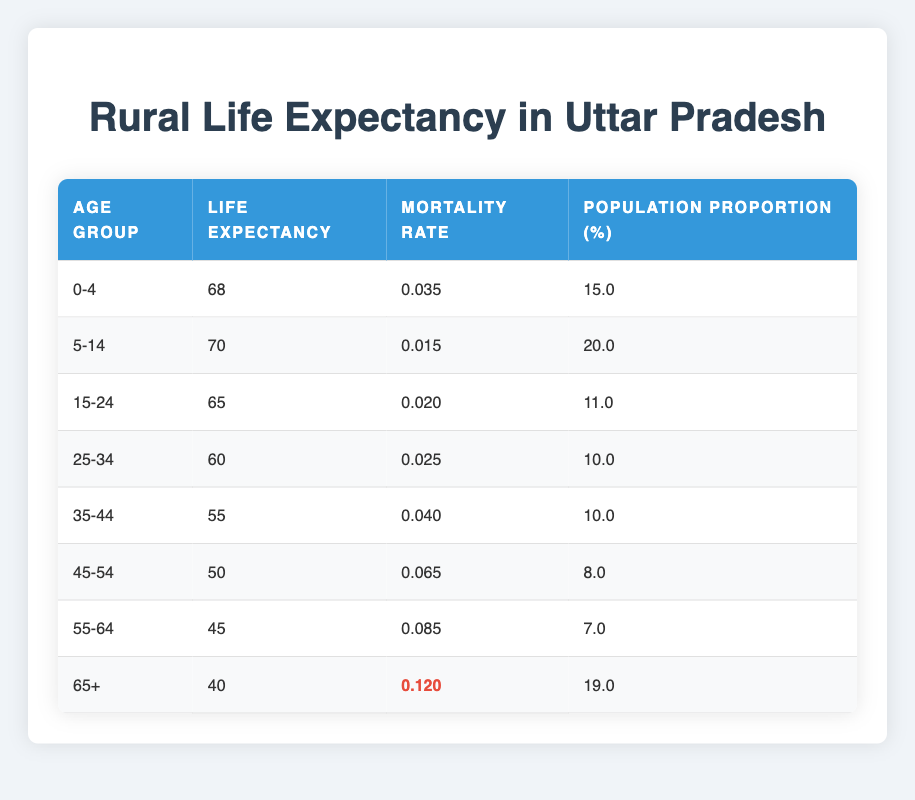What is the life expectancy for the age group 0-4? The life expectancy for this age group is listed directly in the table under the column "Life Expectancy" for the row corresponding to the age range "0-4". The value is 68 years.
Answer: 68 What is the mortality rate for individuals aged 65 and older? The mortality rate for the age group "65+" can be found in the table in the same row. The value is 0.120.
Answer: 0.120 Which age group has the highest population proportion? To find the highest population proportion, we can compare the "Population Proportion (%)" values across all age groups. The age group "5-14" has the highest proportion of 20.0%.
Answer: 5-14 What is the average life expectancy of the age groups 45-54 and 55-64? We take the life expectancy values for the age groups 45-54 (50 years) and 55-64 (45 years), then average them: (50 + 45) / 2 = 47.5 years.
Answer: 47.5 Is the mortality rate for the age group 25-34 higher than that for 15-24? The mortality rates are 0.025 for age 25-34 and 0.020 for 15-24. Since 0.025 is greater than 0.020, the statement is true.
Answer: Yes What is the sum of the life expectancies for the age groups 0-4 and 5-14? We add the life expectancy values from both groups: 68 (for 0-4) + 70 (for 5-14) = 138 years.
Answer: 138 Which age group exhibits the lowest life expectancy? The age group with the lowest life expectancy can be determined by examining the "Life Expectancy" column. The age group "65+" has the lowest life expectancy at 40 years.
Answer: 65+ How does the population proportion of the age group 45-54 compare to that of 25-34? The population proportion for 45-54 is 8.0% and for 25-34 is 10.0%. Since 8.0% is less than 10.0%, it is clear that the 45-54 age group has a lower proportion.
Answer: Lower Is it true that more than half of the population in the age range 55-64 has a life expectancy below 50 years? The life expectancy for the age group 55-64 is 45 years, which is indeed below 50 years. However, to assess 'more than half', we note that the population proportion is only 7.0%, which is not more than half. Hence, the statement is false.
Answer: No 